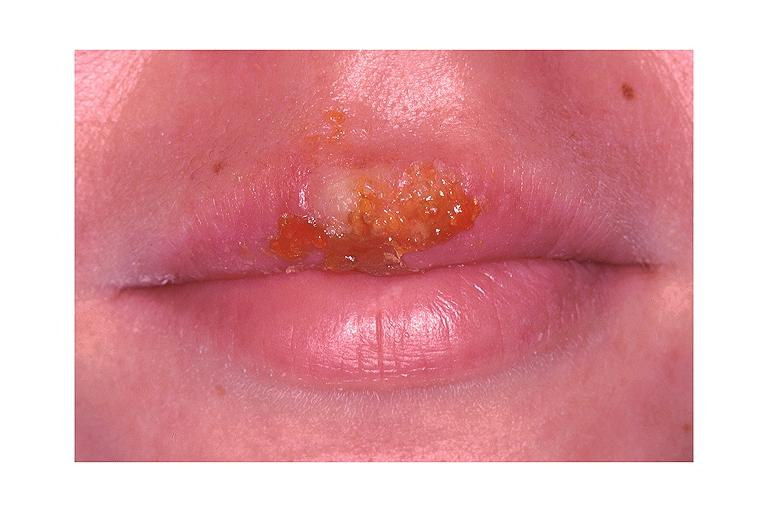where is this?
Answer the question using a single word or phrase. Oral 